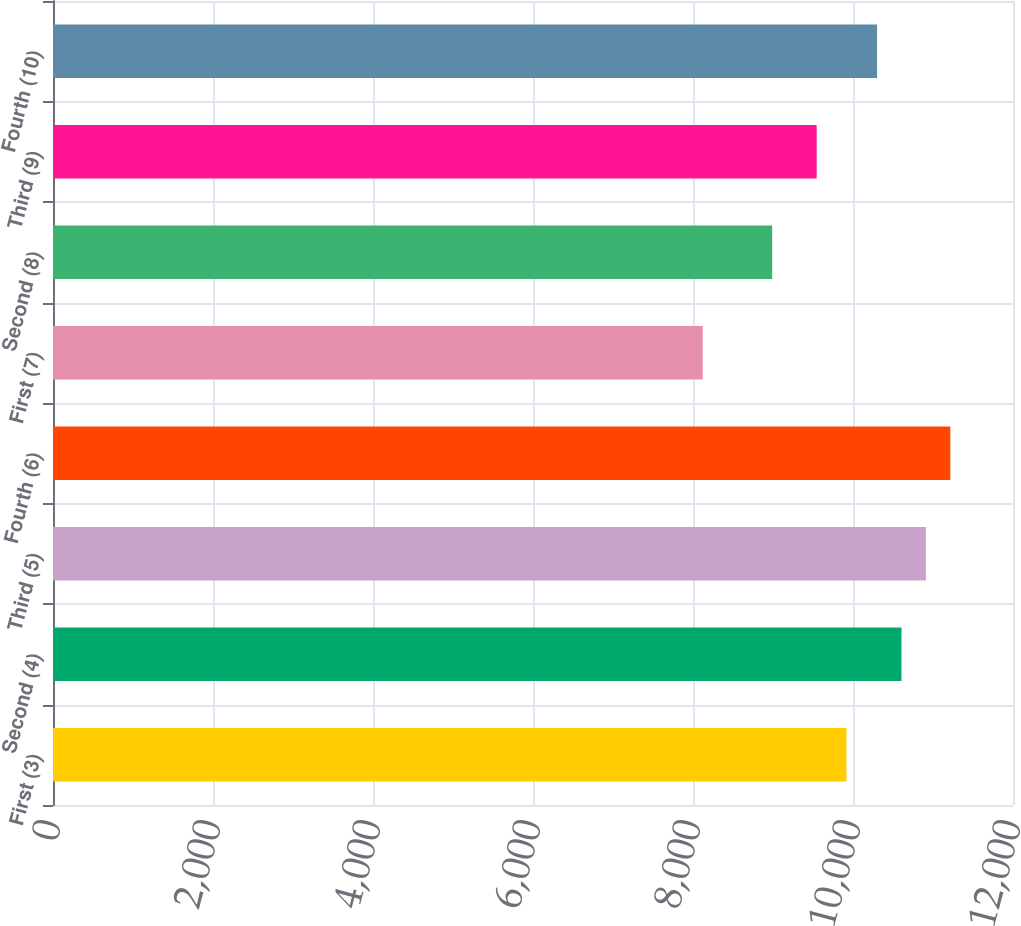<chart> <loc_0><loc_0><loc_500><loc_500><bar_chart><fcel>First (3)<fcel>Second (4)<fcel>Third (5)<fcel>Fourth (6)<fcel>First (7)<fcel>Second (8)<fcel>Third (9)<fcel>Fourth (10)<nl><fcel>9918<fcel>10606.2<fcel>10911.4<fcel>11216.6<fcel>8122<fcel>8990<fcel>9546<fcel>10301<nl></chart> 